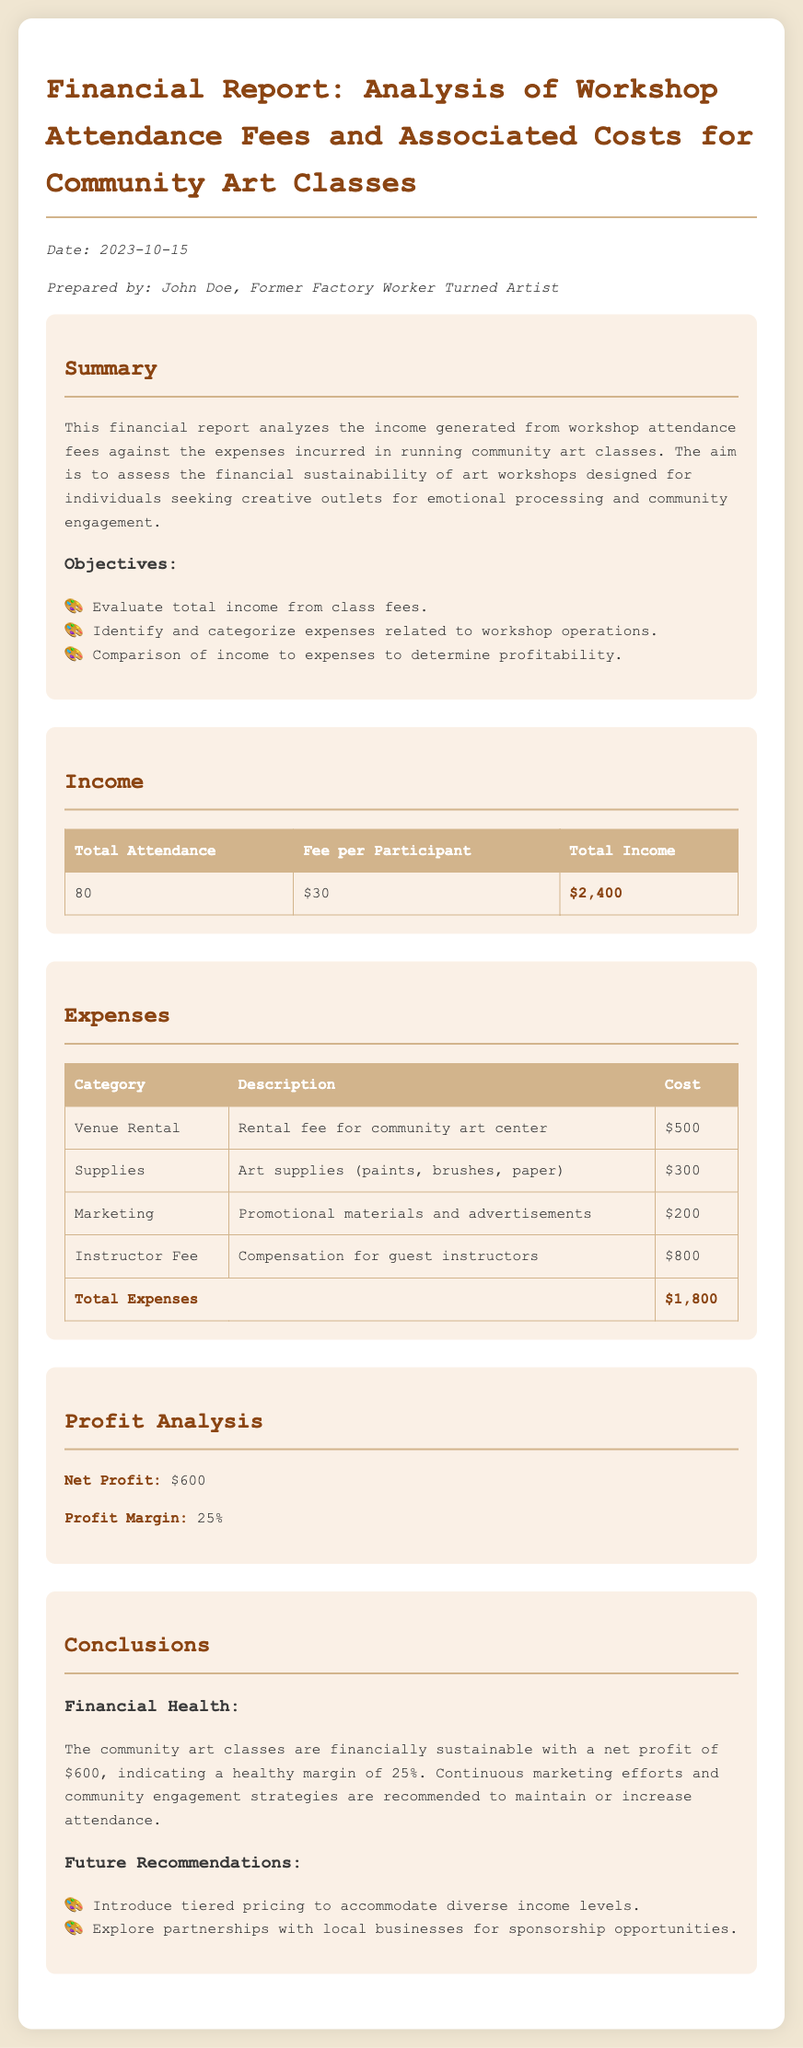What is the total attendance? The total attendance for the workshop is indicated in the income section of the document.
Answer: 80 What is the fee per participant? The fee per participant is listed in the income section of the document.
Answer: $30 What is the total income generated? The total income is calculated based on total attendance multiplied by the fee per participant, as shown in the income table.
Answer: $2,400 What is the total amount spent on venue rental? The venue rental expense is detailed in the expenses section of the report.
Answer: $500 What is the total expenses incurred? The total expenses are summed up in the expenses table of the document.
Answer: $1,800 What is the net profit for the community art classes? The net profit is derived from the total income minus total expenses, as presented in the profit analysis.
Answer: $600 What is the profit margin percentage? The profit margin is calculated based on net profit relative to total income, detailed in the profit analysis section.
Answer: 25% What future recommendation is mentioned regarding pricing? The future recommendations section suggests adjustments to pricing as a strategy for improving financial sustainability.
Answer: Tiered pricing Who prepared the report? The name of the individual who prepared the financial report is mentioned at the beginning of the document.
Answer: John Doe 